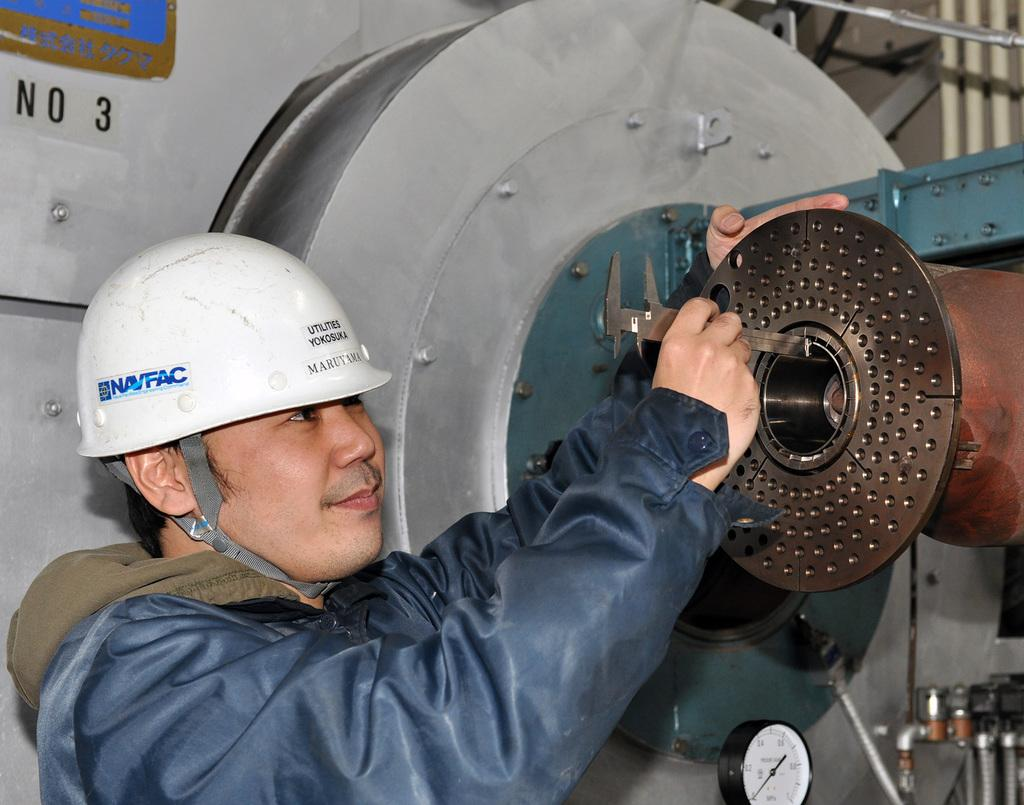Who is present in the image? There is a man in the image. What is the man wearing on his head? The man is wearing a helmet. What type of clothing is the man wearing on his upper body? The man is wearing a jacket. What tool is the man holding in his hand? The man is holding a slide caliper. What can be seen in the background of the image? There is a machine in the image. How does the man end the beef in the image? There is no beef present in the image, and the man is not shown ending any conflict or dispute. 